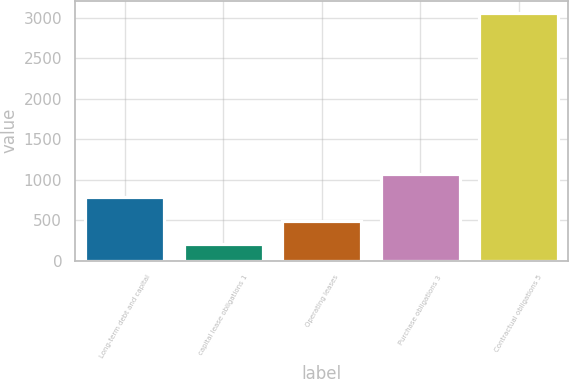<chart> <loc_0><loc_0><loc_500><loc_500><bar_chart><fcel>Long-term debt and capital<fcel>capital lease obligations 1<fcel>Operating leases<fcel>Purchase obligations 3<fcel>Contractual obligations 5<nl><fcel>786<fcel>209<fcel>493.7<fcel>1070.7<fcel>3056<nl></chart> 